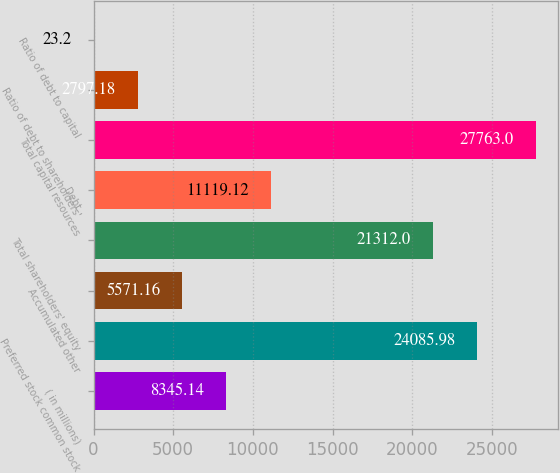Convert chart to OTSL. <chart><loc_0><loc_0><loc_500><loc_500><bar_chart><fcel>( in millions)<fcel>Preferred stock common stock<fcel>Accumulated other<fcel>Total shareholders' equity<fcel>Debt<fcel>Total capital resources<fcel>Ratio of debt to shareholders'<fcel>Ratio of debt to capital<nl><fcel>8345.14<fcel>24086<fcel>5571.16<fcel>21312<fcel>11119.1<fcel>27763<fcel>2797.18<fcel>23.2<nl></chart> 